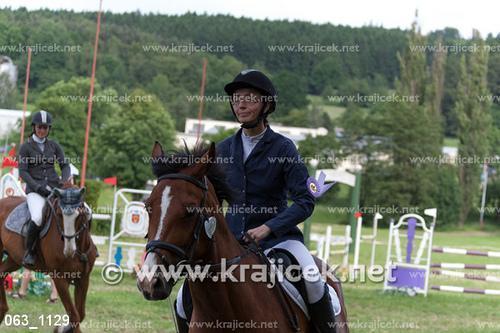How many riders are there?
Give a very brief answer. 2. 